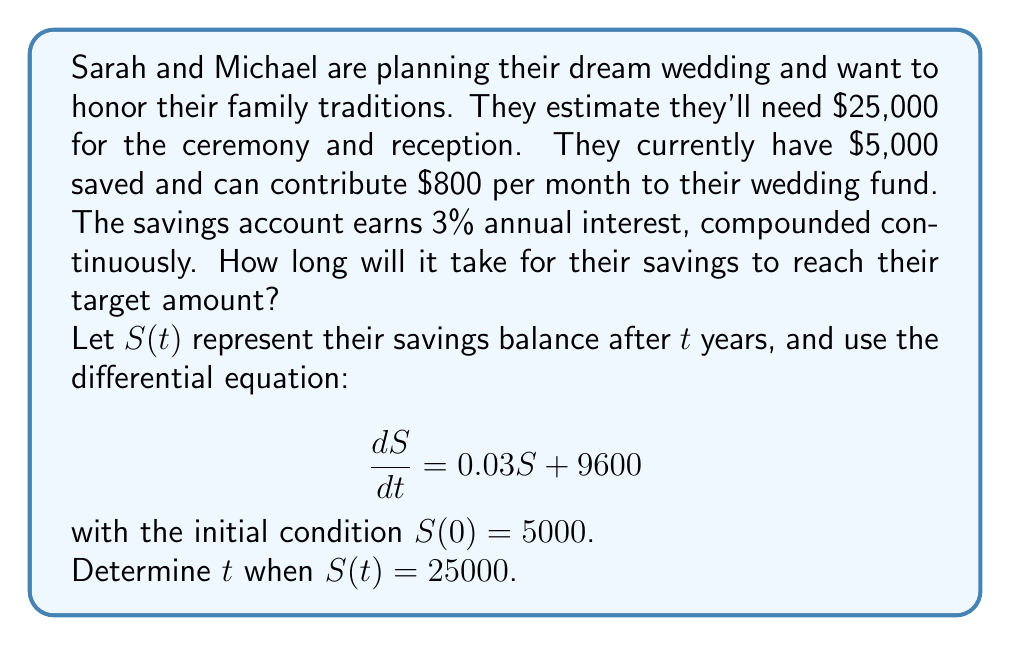Help me with this question. To solve this problem, we'll use the following steps:

1) The given differential equation is:
   $$\frac{dS}{dt} = 0.03S + 9600$$

2) This is a first-order linear differential equation. We can solve it using the integrating factor method.

3) The integrating factor is $e^{\int 0.03 dt} = e^{0.03t}$.

4) Multiplying both sides of the equation by the integrating factor:
   $$e^{0.03t}\frac{dS}{dt} = 0.03e^{0.03t}S + 9600e^{0.03t}$$

5) The left side is now the derivative of $e^{0.03t}S$. So we can write:
   $$\frac{d}{dt}(e^{0.03t}S) = 9600e^{0.03t}$$

6) Integrating both sides:
   $$e^{0.03t}S = 320000e^{0.03t} + C$$

7) Solving for $S$:
   $$S(t) = 320000 + Ce^{-0.03t}$$

8) Using the initial condition $S(0) = 5000$:
   $$5000 = 320000 + C$$
   $$C = -315000$$

9) So the general solution is:
   $$S(t) = 320000 - 315000e^{-0.03t}$$

10) To find when $S(t) = 25000$, we solve:
    $$25000 = 320000 - 315000e^{-0.03t}$$

11) Rearranging:
    $$315000e^{-0.03t} = 295000$$
    $$e^{-0.03t} = \frac{295000}{315000} \approx 0.9365$$

12) Taking the natural log of both sides:
    $$-0.03t = \ln(0.9365) \approx -0.0656$$

13) Solving for $t$:
    $$t = \frac{0.0656}{0.03} \approx 2.19$$

Therefore, it will take approximately 2.19 years for Sarah and Michael's savings to reach their target amount.
Answer: 2.19 years 